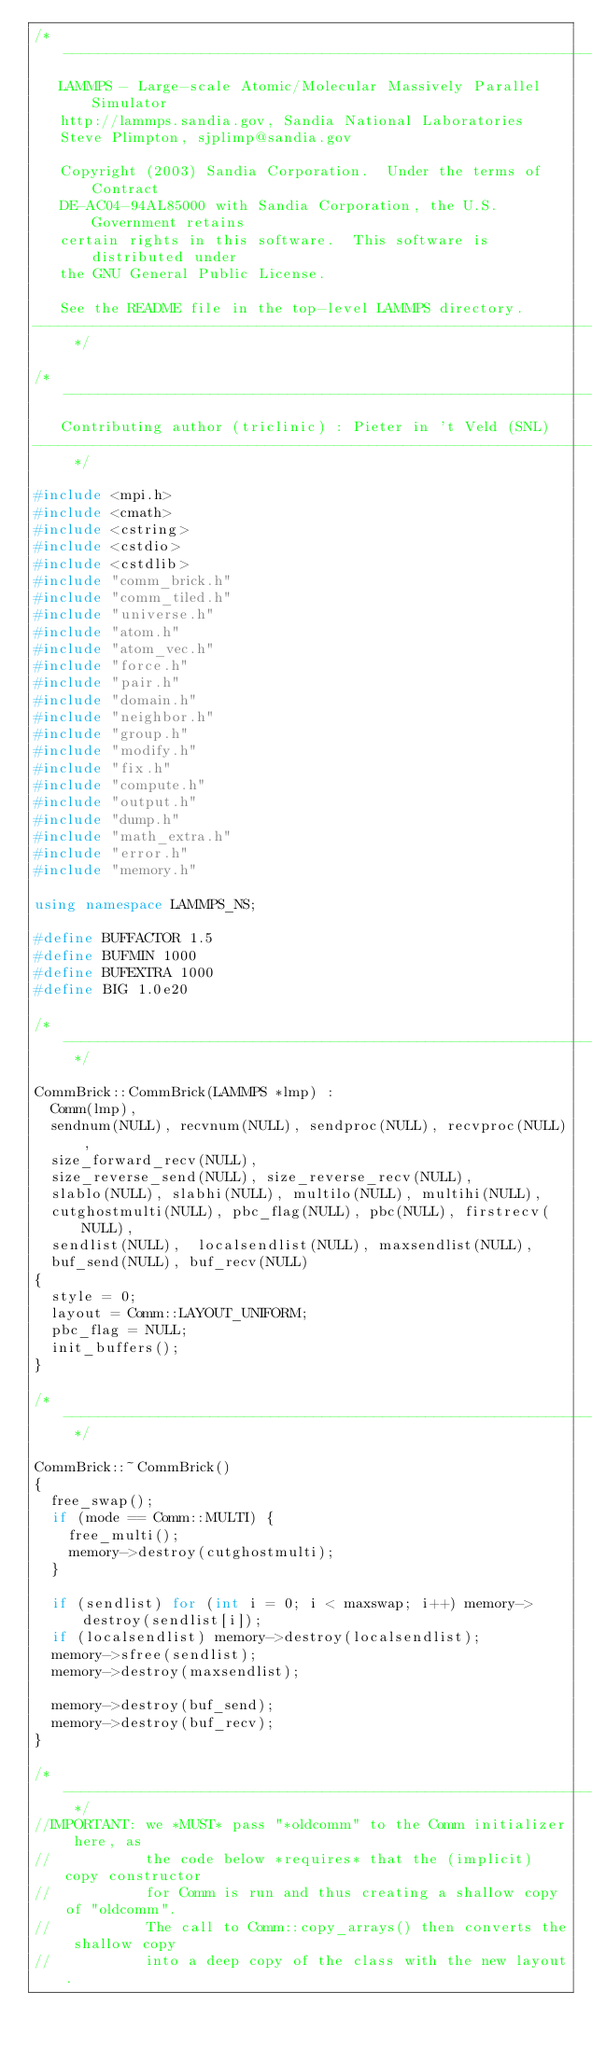Convert code to text. <code><loc_0><loc_0><loc_500><loc_500><_C++_>/* ----------------------------------------------------------------------
   LAMMPS - Large-scale Atomic/Molecular Massively Parallel Simulator
   http://lammps.sandia.gov, Sandia National Laboratories
   Steve Plimpton, sjplimp@sandia.gov

   Copyright (2003) Sandia Corporation.  Under the terms of Contract
   DE-AC04-94AL85000 with Sandia Corporation, the U.S. Government retains
   certain rights in this software.  This software is distributed under
   the GNU General Public License.

   See the README file in the top-level LAMMPS directory.
------------------------------------------------------------------------- */

/* ----------------------------------------------------------------------
   Contributing author (triclinic) : Pieter in 't Veld (SNL)
------------------------------------------------------------------------- */

#include <mpi.h>
#include <cmath>
#include <cstring>
#include <cstdio>
#include <cstdlib>
#include "comm_brick.h"
#include "comm_tiled.h"
#include "universe.h"
#include "atom.h"
#include "atom_vec.h"
#include "force.h"
#include "pair.h"
#include "domain.h"
#include "neighbor.h"
#include "group.h"
#include "modify.h"
#include "fix.h"
#include "compute.h"
#include "output.h"
#include "dump.h"
#include "math_extra.h"
#include "error.h"
#include "memory.h"

using namespace LAMMPS_NS;

#define BUFFACTOR 1.5
#define BUFMIN 1000
#define BUFEXTRA 1000
#define BIG 1.0e20

/* ---------------------------------------------------------------------- */

CommBrick::CommBrick(LAMMPS *lmp) :
  Comm(lmp),
  sendnum(NULL), recvnum(NULL), sendproc(NULL), recvproc(NULL),
  size_forward_recv(NULL),
  size_reverse_send(NULL), size_reverse_recv(NULL),
  slablo(NULL), slabhi(NULL), multilo(NULL), multihi(NULL),
  cutghostmulti(NULL), pbc_flag(NULL), pbc(NULL), firstrecv(NULL),
  sendlist(NULL),  localsendlist(NULL), maxsendlist(NULL),
  buf_send(NULL), buf_recv(NULL)
{
  style = 0;
  layout = Comm::LAYOUT_UNIFORM;
  pbc_flag = NULL;
  init_buffers();
}

/* ---------------------------------------------------------------------- */

CommBrick::~CommBrick()
{
  free_swap();
  if (mode == Comm::MULTI) {
    free_multi();
    memory->destroy(cutghostmulti);
  }

  if (sendlist) for (int i = 0; i < maxswap; i++) memory->destroy(sendlist[i]);
  if (localsendlist) memory->destroy(localsendlist);
  memory->sfree(sendlist);
  memory->destroy(maxsendlist);

  memory->destroy(buf_send);
  memory->destroy(buf_recv);
}

/* ---------------------------------------------------------------------- */
//IMPORTANT: we *MUST* pass "*oldcomm" to the Comm initializer here, as
//           the code below *requires* that the (implicit) copy constructor
//           for Comm is run and thus creating a shallow copy of "oldcomm".
//           The call to Comm::copy_arrays() then converts the shallow copy
//           into a deep copy of the class with the new layout.
</code> 